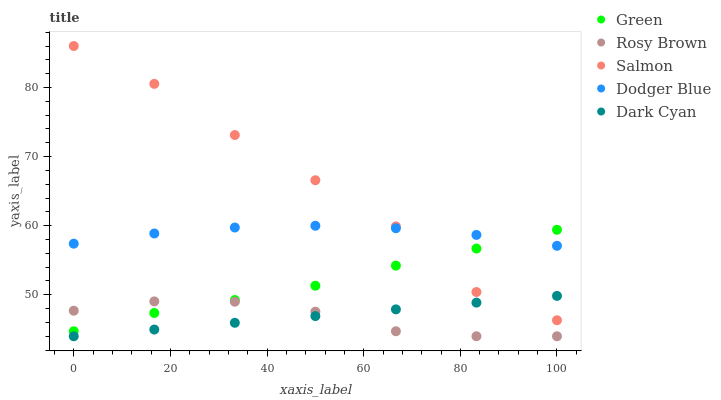Does Rosy Brown have the minimum area under the curve?
Answer yes or no. Yes. Does Salmon have the maximum area under the curve?
Answer yes or no. Yes. Does Salmon have the minimum area under the curve?
Answer yes or no. No. Does Rosy Brown have the maximum area under the curve?
Answer yes or no. No. Is Dark Cyan the smoothest?
Answer yes or no. Yes. Is Salmon the roughest?
Answer yes or no. Yes. Is Rosy Brown the smoothest?
Answer yes or no. No. Is Rosy Brown the roughest?
Answer yes or no. No. Does Dark Cyan have the lowest value?
Answer yes or no. Yes. Does Salmon have the lowest value?
Answer yes or no. No. Does Salmon have the highest value?
Answer yes or no. Yes. Does Rosy Brown have the highest value?
Answer yes or no. No. Is Rosy Brown less than Salmon?
Answer yes or no. Yes. Is Green greater than Dark Cyan?
Answer yes or no. Yes. Does Salmon intersect Dodger Blue?
Answer yes or no. Yes. Is Salmon less than Dodger Blue?
Answer yes or no. No. Is Salmon greater than Dodger Blue?
Answer yes or no. No. Does Rosy Brown intersect Salmon?
Answer yes or no. No. 